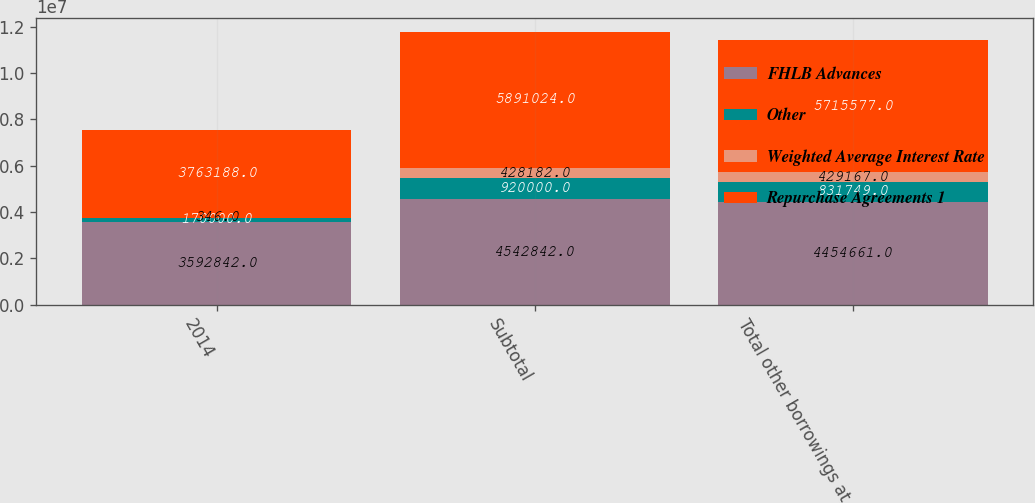Convert chart. <chart><loc_0><loc_0><loc_500><loc_500><stacked_bar_chart><ecel><fcel>2014<fcel>Subtotal<fcel>Total other borrowings at<nl><fcel>FHLB Advances<fcel>3.59284e+06<fcel>4.54284e+06<fcel>4.45466e+06<nl><fcel>Other<fcel>170000<fcel>920000<fcel>831749<nl><fcel>Weighted Average Interest Rate<fcel>346<fcel>428182<fcel>429167<nl><fcel>Repurchase Agreements 1<fcel>3.76319e+06<fcel>5.89102e+06<fcel>5.71558e+06<nl></chart> 